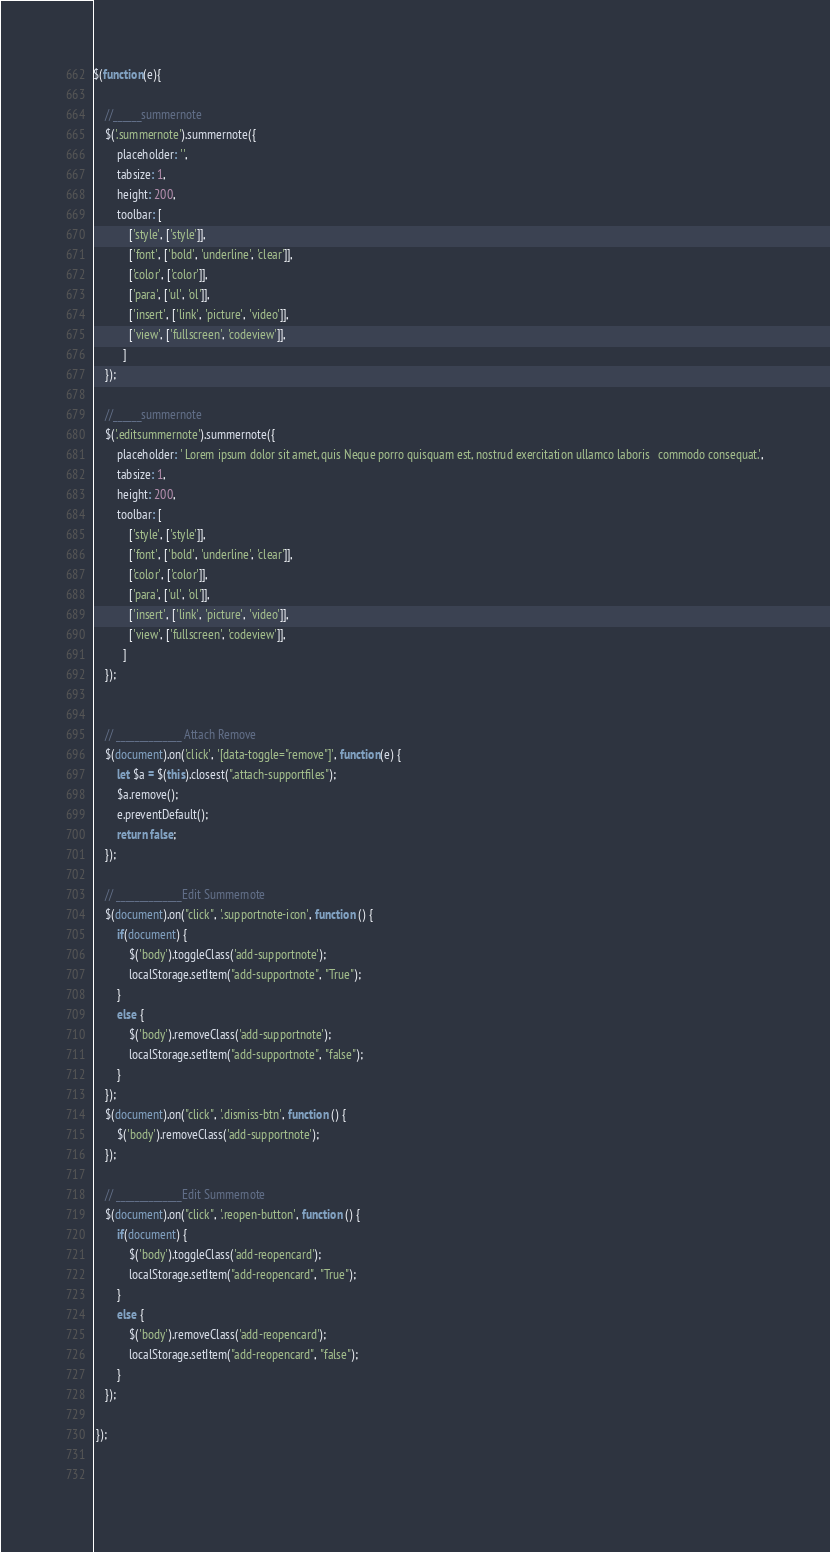Convert code to text. <code><loc_0><loc_0><loc_500><loc_500><_JavaScript_>$(function(e){

	//______summernote
	$('.summernote').summernote({
		placeholder: '',
		tabsize: 1,
		height: 200,
		toolbar: [
			['style', ['style']],
			['font', ['bold', 'underline', 'clear']],
			['color', ['color']],
			['para', ['ul', 'ol']],
			['insert', ['link', 'picture', 'video']],
			['view', ['fullscreen', 'codeview']],
		  ]
	});

	//______summernote
	$('.editsummernote').summernote({
		placeholder: ' Lorem ipsum dolor sit amet, quis Neque porro quisquam est, nostrud exercitation ullamco laboris   commodo consequat.',
		tabsize: 1,
		height: 200,
		toolbar: [
			['style', ['style']],
			['font', ['bold', 'underline', 'clear']],
			['color', ['color']],
			['para', ['ul', 'ol']],
			['insert', ['link', 'picture', 'video']],
			['view', ['fullscreen', 'codeview']],
		  ]
	});

	
	// ______________ Attach Remove
	$(document).on('click', '[data-toggle="remove"]', function(e) {
		let $a = $(this).closest(".attach-supportfiles");
		$a.remove();
		e.preventDefault();
		return false;
	});

	// ______________Edit Summernote
	$(document).on("click", '.supportnote-icon', function () {    
		if(document) {
			$('body').toggleClass('add-supportnote');
			localStorage.setItem("add-supportnote", "True");
		}
		else {
			$('body').removeClass('add-supportnote');
			localStorage.setItem("add-supportnote", "false");
		}
	});
	$(document).on("click", '.dismiss-btn', function () {    
		$('body').removeClass('add-supportnote');
	});

	// ______________Edit Summernote
	$(document).on("click", '.reopen-button', function () {    
		if(document) {
			$('body').toggleClass('add-reopencard');
			localStorage.setItem("add-reopencard", "True");
		}
		else {
			$('body').removeClass('add-reopencard');
			localStorage.setItem("add-reopencard", "false");
		}
	});

 });

 </code> 